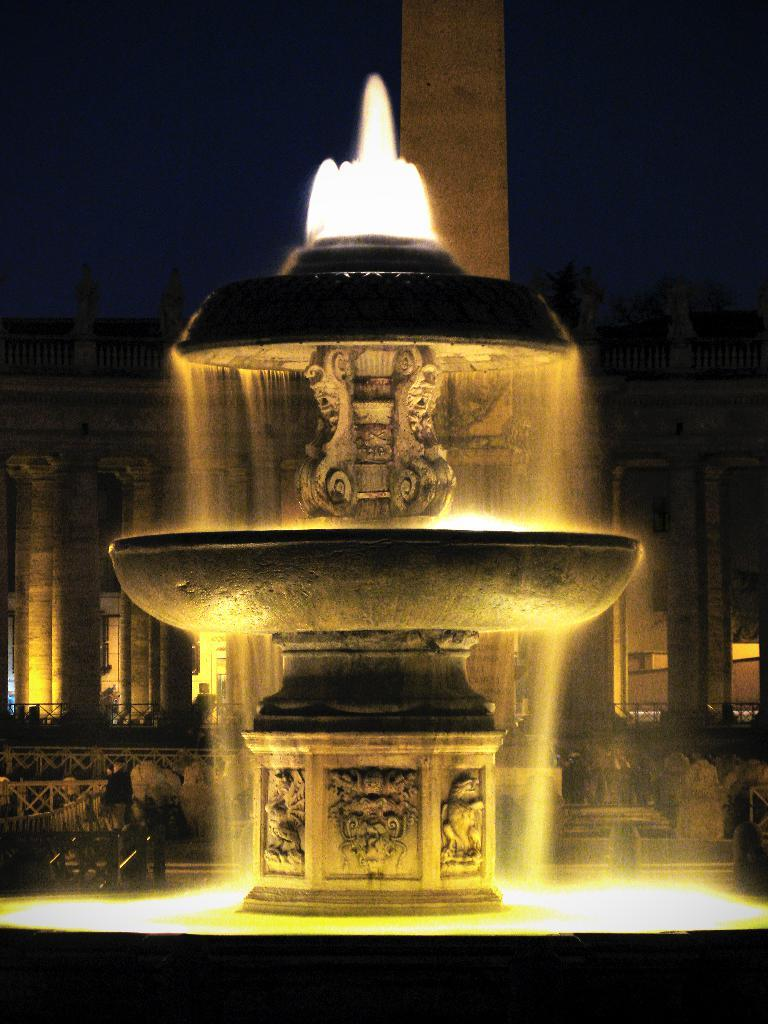What is the main subject of the image? The main subject of the image is a fountain. How is the fountain described? The fountain is described as beautiful. Where is the fountain located in relation to the building? The fountain is in front of a building. What time of day is the image captured? The image is captured at night time. How many eggs are visible in the image? There are no eggs present in the image. What type of window can be seen in the image? The image does not show any windows; it features a fountain in front of a building at night time. 